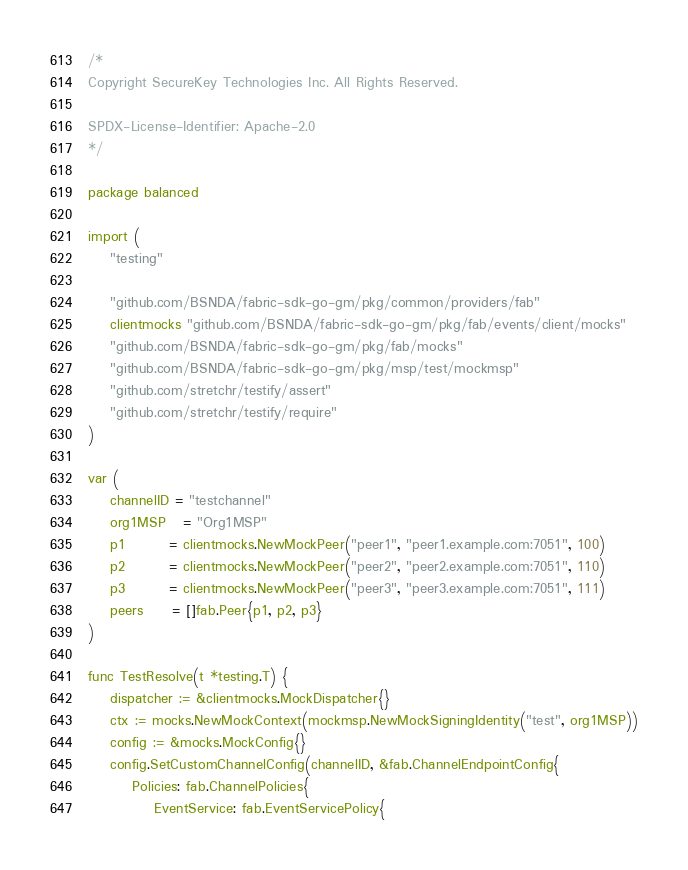<code> <loc_0><loc_0><loc_500><loc_500><_Go_>/*
Copyright SecureKey Technologies Inc. All Rights Reserved.

SPDX-License-Identifier: Apache-2.0
*/

package balanced

import (
	"testing"

	"github.com/BSNDA/fabric-sdk-go-gm/pkg/common/providers/fab"
	clientmocks "github.com/BSNDA/fabric-sdk-go-gm/pkg/fab/events/client/mocks"
	"github.com/BSNDA/fabric-sdk-go-gm/pkg/fab/mocks"
	"github.com/BSNDA/fabric-sdk-go-gm/pkg/msp/test/mockmsp"
	"github.com/stretchr/testify/assert"
	"github.com/stretchr/testify/require"
)

var (
	channelID = "testchannel"
	org1MSP   = "Org1MSP"
	p1        = clientmocks.NewMockPeer("peer1", "peer1.example.com:7051", 100)
	p2        = clientmocks.NewMockPeer("peer2", "peer2.example.com:7051", 110)
	p3        = clientmocks.NewMockPeer("peer3", "peer3.example.com:7051", 111)
	peers     = []fab.Peer{p1, p2, p3}
)

func TestResolve(t *testing.T) {
	dispatcher := &clientmocks.MockDispatcher{}
	ctx := mocks.NewMockContext(mockmsp.NewMockSigningIdentity("test", org1MSP))
	config := &mocks.MockConfig{}
	config.SetCustomChannelConfig(channelID, &fab.ChannelEndpointConfig{
		Policies: fab.ChannelPolicies{
			EventService: fab.EventServicePolicy{</code> 